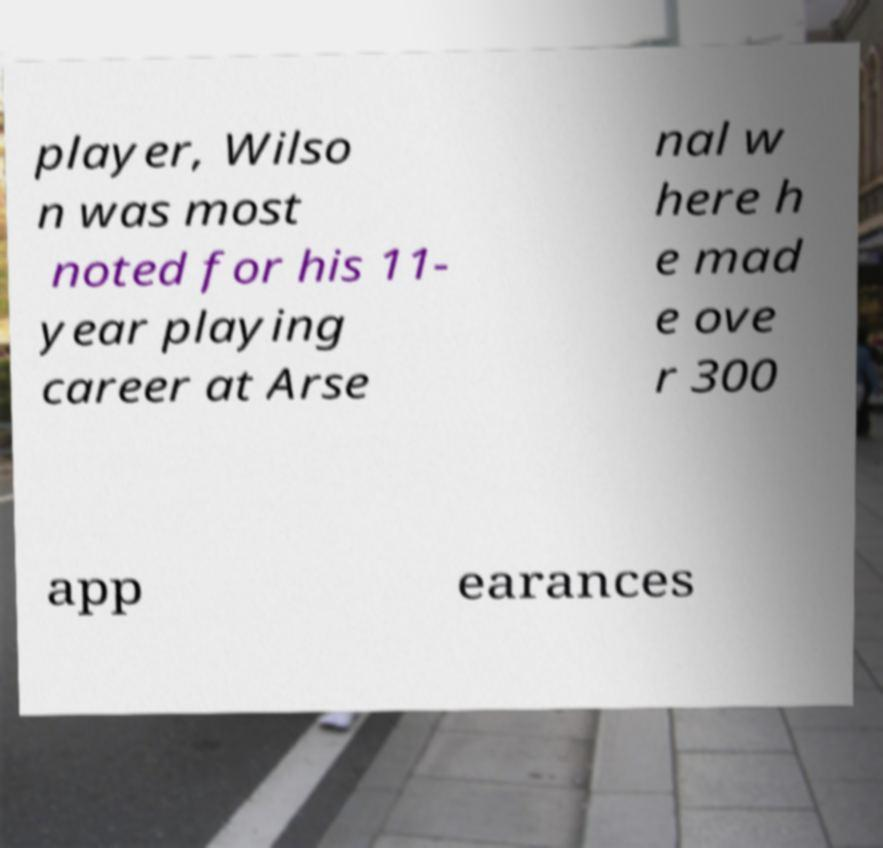I need the written content from this picture converted into text. Can you do that? player, Wilso n was most noted for his 11- year playing career at Arse nal w here h e mad e ove r 300 app earances 